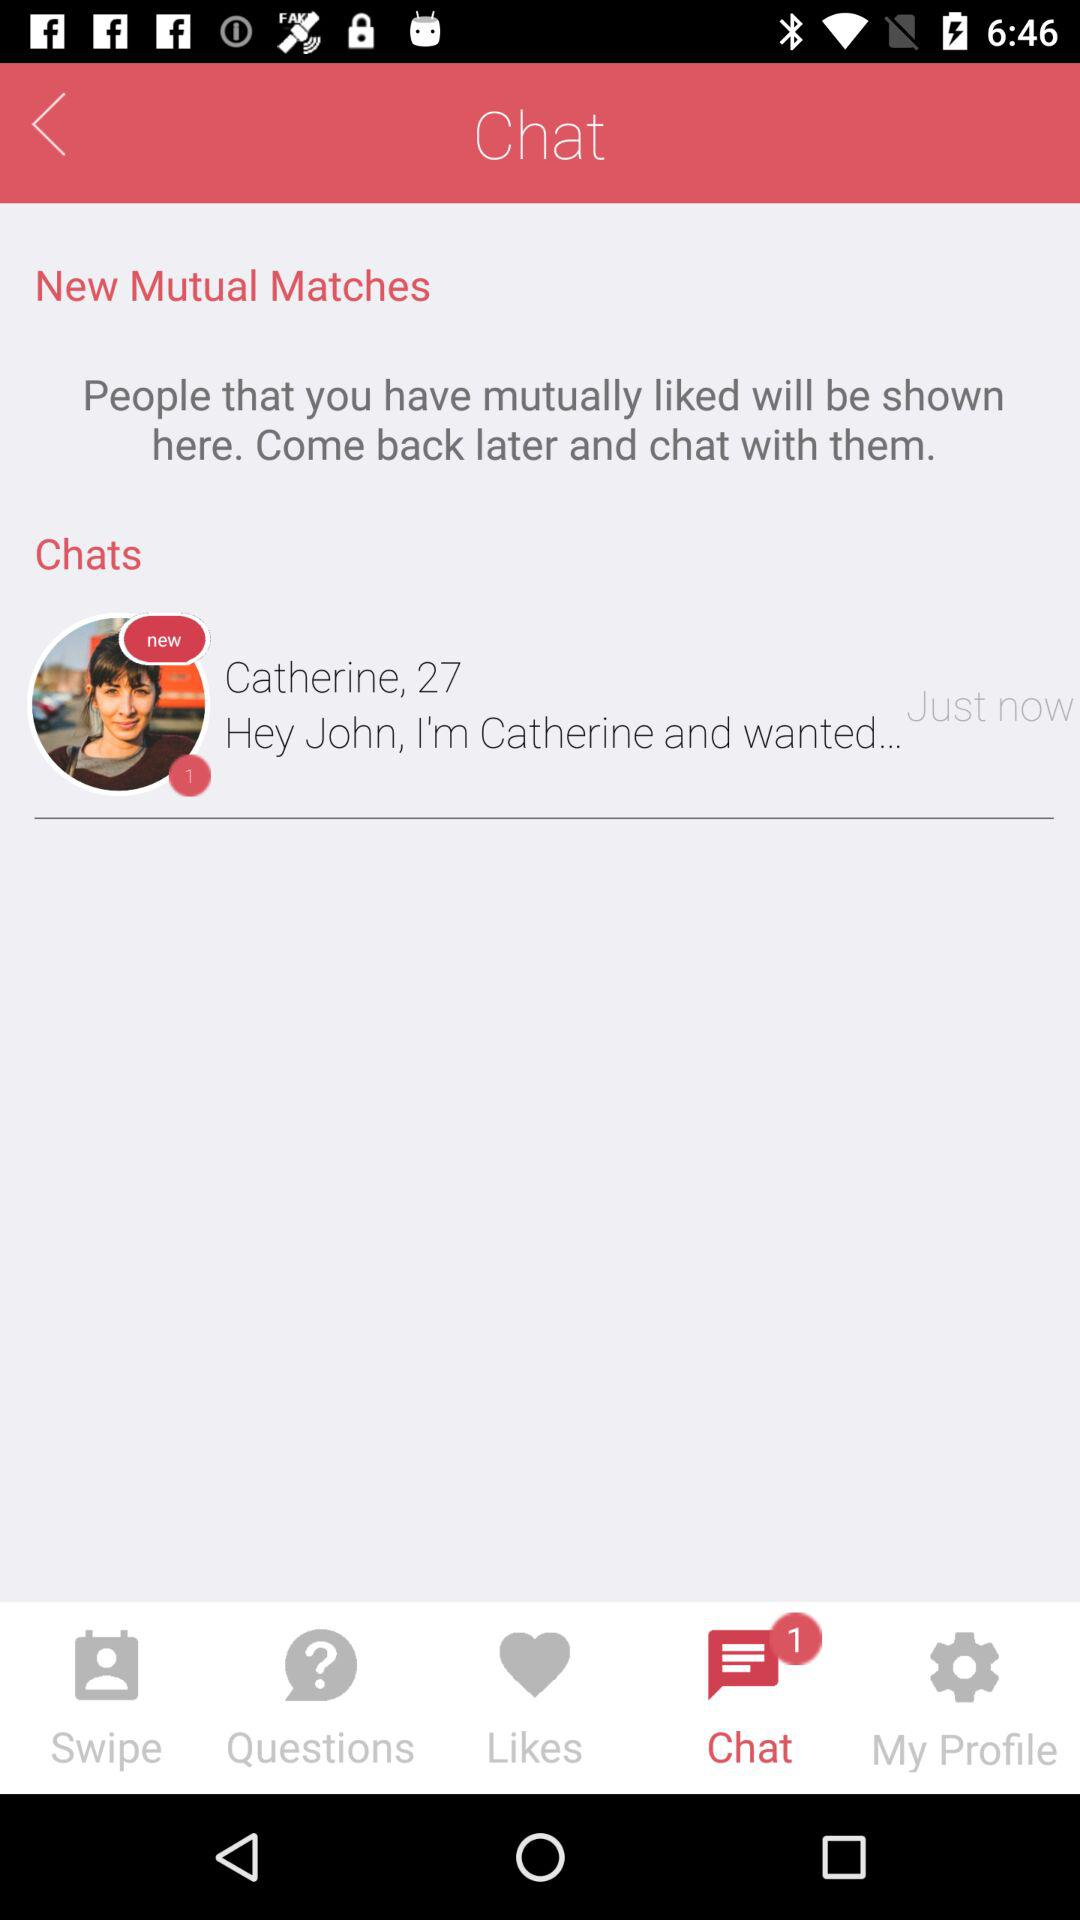How many new message notifications are there? There is 1 new message notification. 